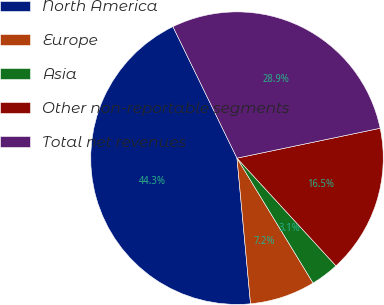<chart> <loc_0><loc_0><loc_500><loc_500><pie_chart><fcel>North America<fcel>Europe<fcel>Asia<fcel>Other non-reportable segments<fcel>Total net revenues<nl><fcel>44.26%<fcel>7.23%<fcel>3.12%<fcel>16.45%<fcel>28.94%<nl></chart> 